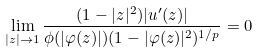Convert formula to latex. <formula><loc_0><loc_0><loc_500><loc_500>\lim _ { | z | \rightarrow 1 } \frac { ( 1 - | z | ^ { 2 } ) | u ^ { \prime } ( z ) | } { \phi ( | \varphi ( z ) | ) ( 1 - | \varphi ( z ) | ^ { 2 } ) ^ { 1 / p } } = 0</formula> 